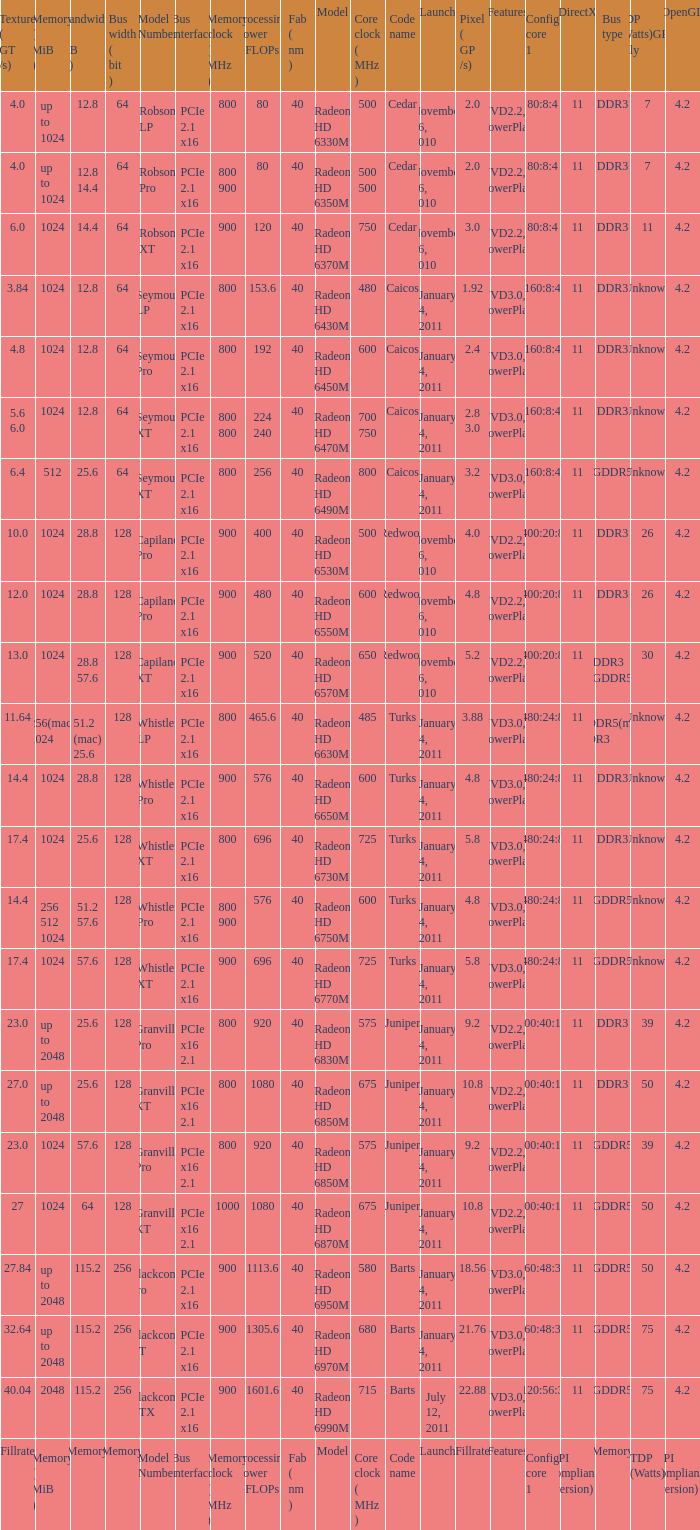What is every bus type for the texture of fillrate? Memory. 